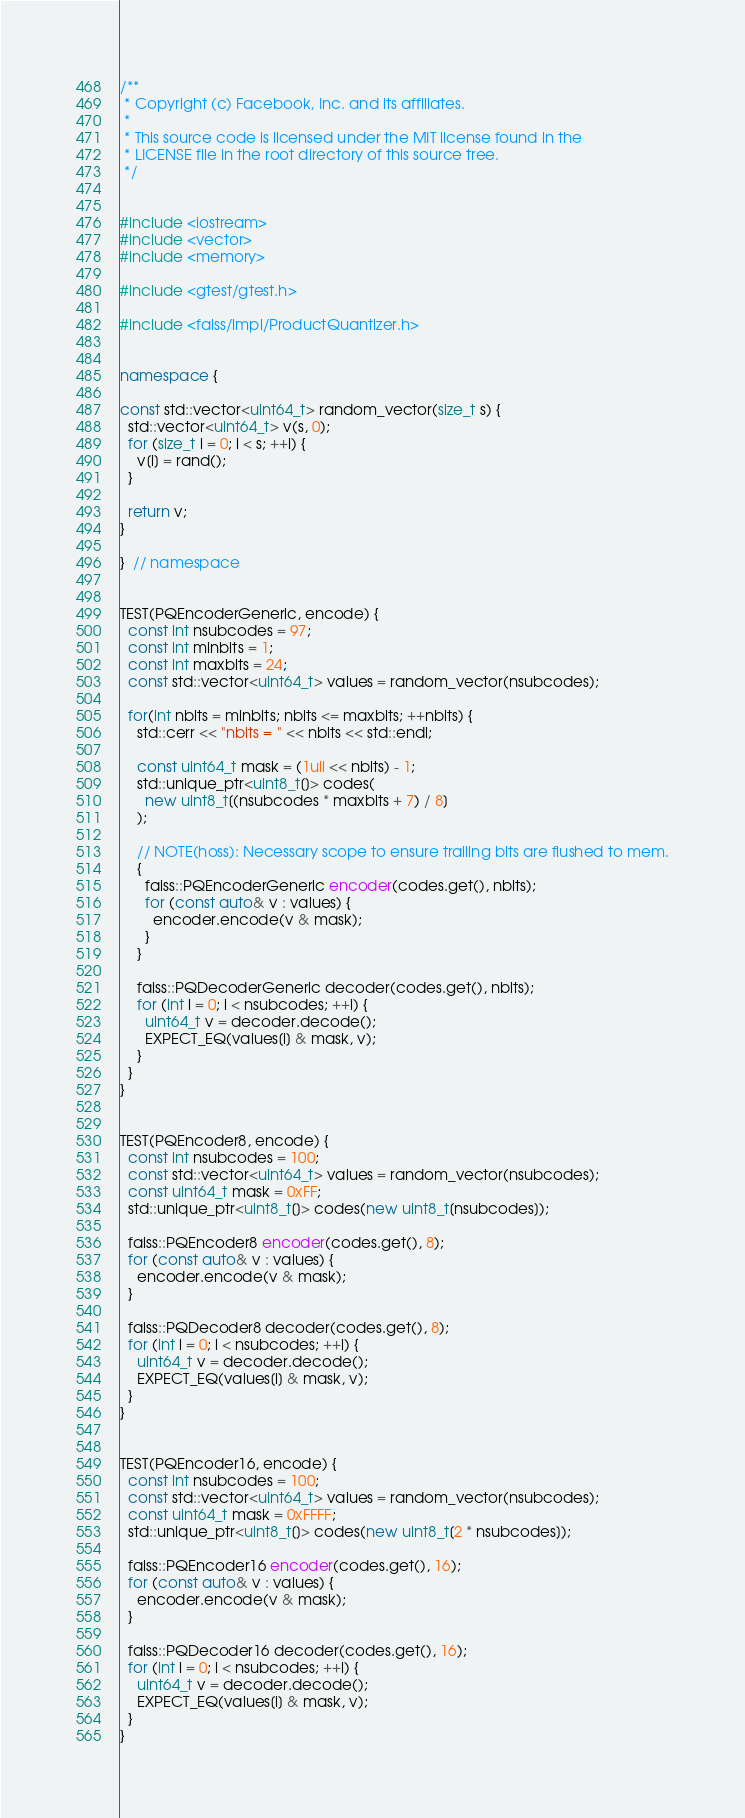<code> <loc_0><loc_0><loc_500><loc_500><_C++_>/**
 * Copyright (c) Facebook, Inc. and its affiliates.
 *
 * This source code is licensed under the MIT license found in the
 * LICENSE file in the root directory of this source tree.
 */


#include <iostream>
#include <vector>
#include <memory>

#include <gtest/gtest.h>

#include <faiss/impl/ProductQuantizer.h>


namespace {

const std::vector<uint64_t> random_vector(size_t s) {
  std::vector<uint64_t> v(s, 0);
  for (size_t i = 0; i < s; ++i) {
    v[i] = rand();
  }

  return v;
}

}  // namespace


TEST(PQEncoderGeneric, encode) {
  const int nsubcodes = 97;
  const int minbits = 1;
  const int maxbits = 24;
  const std::vector<uint64_t> values = random_vector(nsubcodes);

  for(int nbits = minbits; nbits <= maxbits; ++nbits) {
    std::cerr << "nbits = " << nbits << std::endl;

    const uint64_t mask = (1ull << nbits) - 1;
    std::unique_ptr<uint8_t[]> codes(
      new uint8_t[(nsubcodes * maxbits + 7) / 8]
    );

    // NOTE(hoss): Necessary scope to ensure trailing bits are flushed to mem.
    {
      faiss::PQEncoderGeneric encoder(codes.get(), nbits);
      for (const auto& v : values) {
        encoder.encode(v & mask);
      }
    }

    faiss::PQDecoderGeneric decoder(codes.get(), nbits);
    for (int i = 0; i < nsubcodes; ++i) {
      uint64_t v = decoder.decode();
      EXPECT_EQ(values[i] & mask, v);
    }
  }
}


TEST(PQEncoder8, encode) {
  const int nsubcodes = 100;
  const std::vector<uint64_t> values = random_vector(nsubcodes);
  const uint64_t mask = 0xFF;
  std::unique_ptr<uint8_t[]> codes(new uint8_t[nsubcodes]);

  faiss::PQEncoder8 encoder(codes.get(), 8);
  for (const auto& v : values) {
    encoder.encode(v & mask);
  }

  faiss::PQDecoder8 decoder(codes.get(), 8);
  for (int i = 0; i < nsubcodes; ++i) {
    uint64_t v = decoder.decode();
    EXPECT_EQ(values[i] & mask, v);
  }
}


TEST(PQEncoder16, encode) {
  const int nsubcodes = 100;
  const std::vector<uint64_t> values = random_vector(nsubcodes);
  const uint64_t mask = 0xFFFF;
  std::unique_ptr<uint8_t[]> codes(new uint8_t[2 * nsubcodes]);

  faiss::PQEncoder16 encoder(codes.get(), 16);
  for (const auto& v : values) {
    encoder.encode(v & mask);
  }

  faiss::PQDecoder16 decoder(codes.get(), 16);
  for (int i = 0; i < nsubcodes; ++i) {
    uint64_t v = decoder.decode();
    EXPECT_EQ(values[i] & mask, v);
  }
}
</code> 